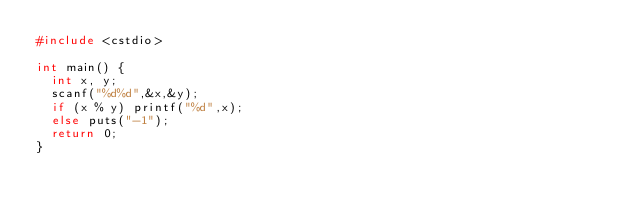<code> <loc_0><loc_0><loc_500><loc_500><_C++_>#include <cstdio>

int main() {
	int x, y;
	scanf("%d%d",&x,&y);
	if (x % y) printf("%d",x);
	else puts("-1");
	return 0;
}
</code> 